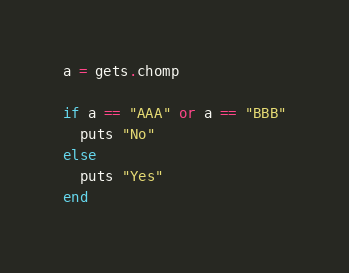<code> <loc_0><loc_0><loc_500><loc_500><_Ruby_>a = gets.chomp

if a == "AAA" or a == "BBB"
  puts "No"
else
  puts "Yes"
end</code> 